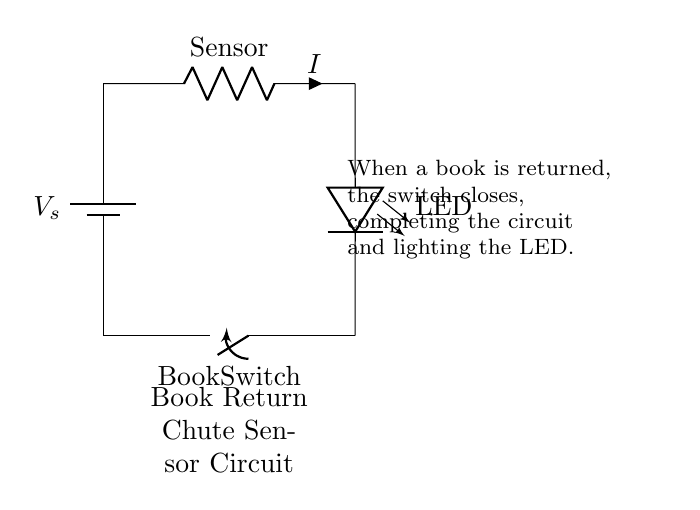What is the power source in this circuit? The circuit is powered by a battery, which is represented as 'V_s' in the diagram. This indicates that the circuit requires a voltage source to operate.
Answer: Battery What does the resistor represent in the circuit? The resistor labeled 'Sensor' in the circuit diagram indicates that it is simulating the behavior of a sensor within the book return chute system, which is crucial for detecting the presence of a book.
Answer: Sensor What happens when the book switch is closed? When the book switch closes, the circuit is completed, allowing current to flow from the power source through the resistor and the LED, which causes the LED to light up.
Answer: LED lights up How many components are present in this circuit? The circuit contains four components: one battery, one resistor, one LED, and one switch. As each component plays a role in the functioning of the circuit, counting them gives us the total.
Answer: Four What type of circuit is this? This circuit is a series circuit as all components are connected in a single path, ensuring that current flows through each component sequentially.
Answer: Series What is the role of the LED in this circuit? The LED serves as an indicator light, which visually signals the status of the circuit; when the switch closes due to a book being returned, the LED lights up to show that the circuit is active.
Answer: Indicator light What indicates the activation in this circuit? The switch labeled 'Book Switch' indicates activation; when the book is placed into the chute, it closes the switch, completing the circuit and enabling the LED to function.
Answer: Book Switch 